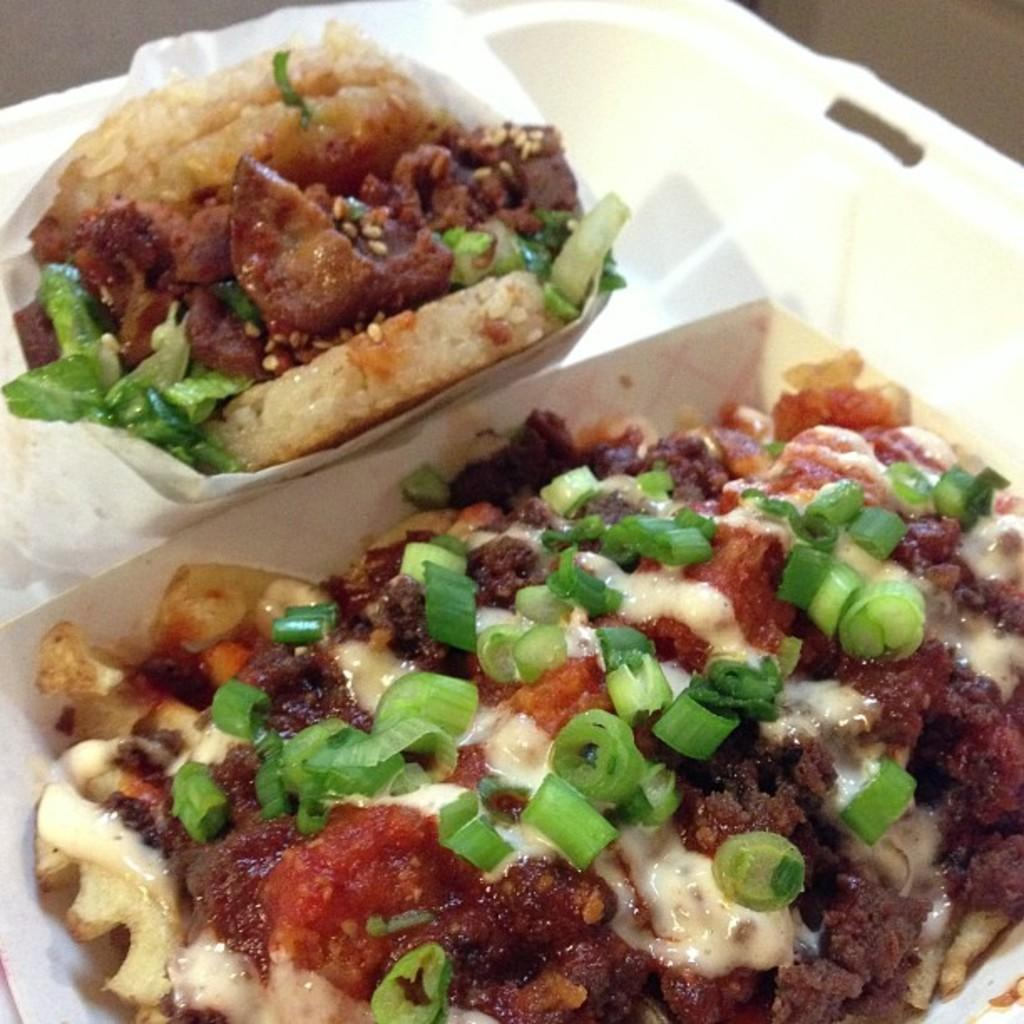What object is present in the image? There is a container in the image. What color is the container? The container is white in color. What can be found inside the container? There are food items in the container. What type of skirt is being worn by the maid in the image? There is no maid or skirt present in the image; it only features a white container with food items inside. 